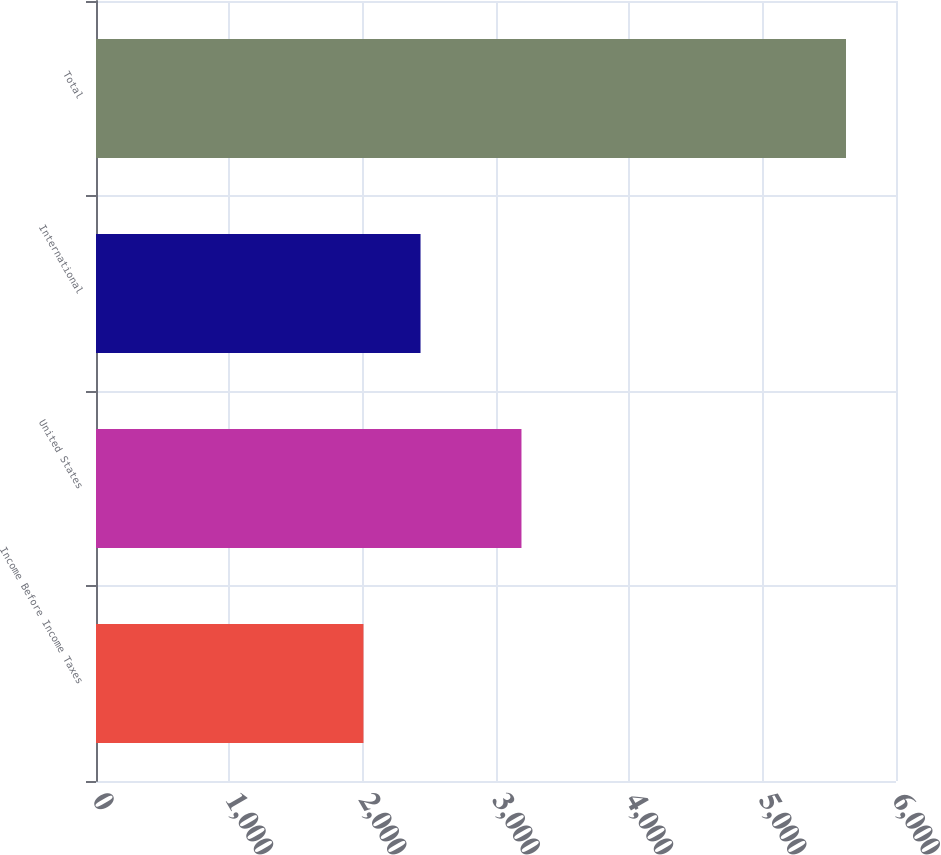Convert chart to OTSL. <chart><loc_0><loc_0><loc_500><loc_500><bar_chart><fcel>Income Before Income Taxes<fcel>United States<fcel>International<fcel>Total<nl><fcel>2006<fcel>3191<fcel>2434<fcel>5625<nl></chart> 